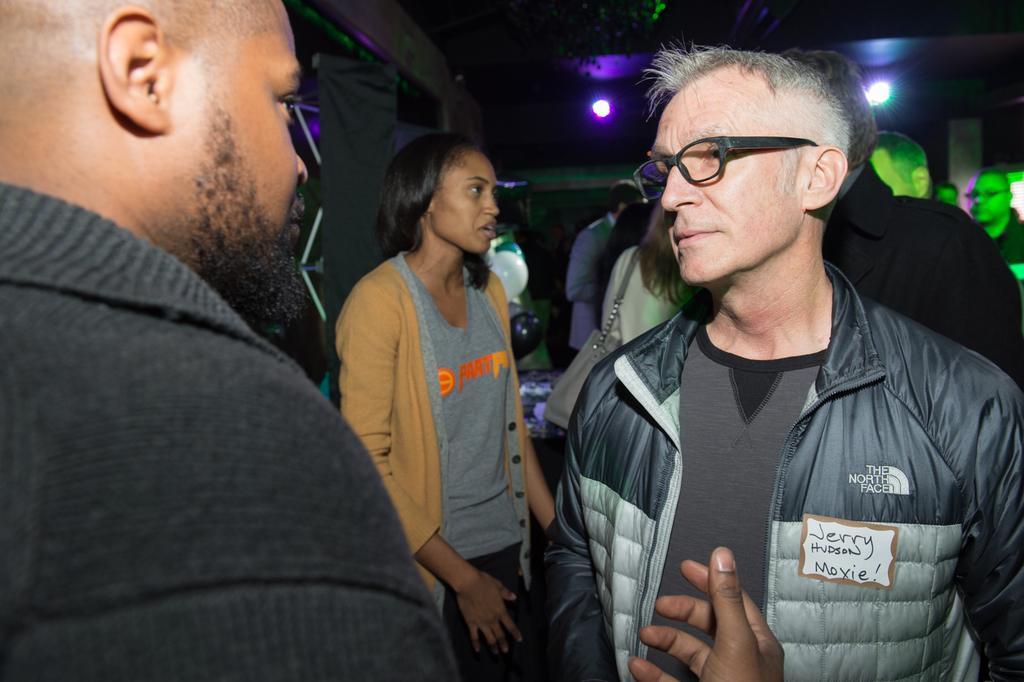How would you summarize this image in a sentence or two? In this image there are people standing. In the background there are lights and a wall. 